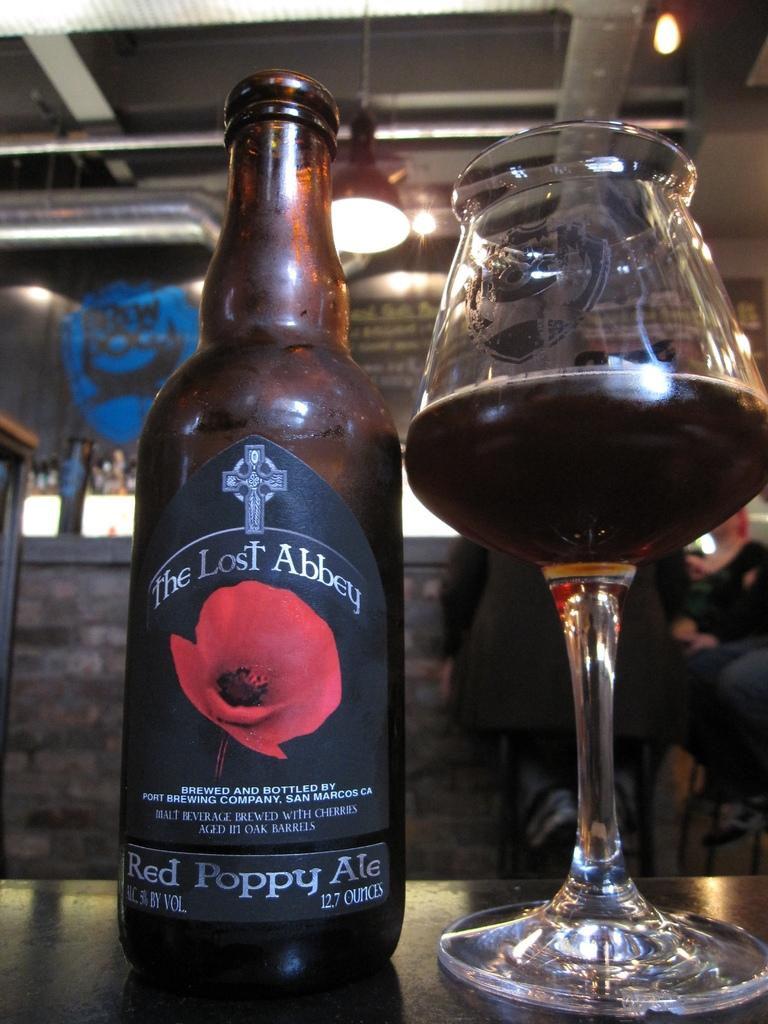What is in the bottle that is visible in the image? There is a bottle with a label in the image. What is in the glass that is visible in the image? There is a glass with a drink in the image. Where are the bottle and glass located in the image? Both the bottle and glass are placed on a table in the image. What can be seen in the background of the image? There are persons, lights, and a wall visible in the background of the image. What type of machine is visible in the image? There is no machine present in the image. Is there a train visible in the image? No, there is no train present in the image. 